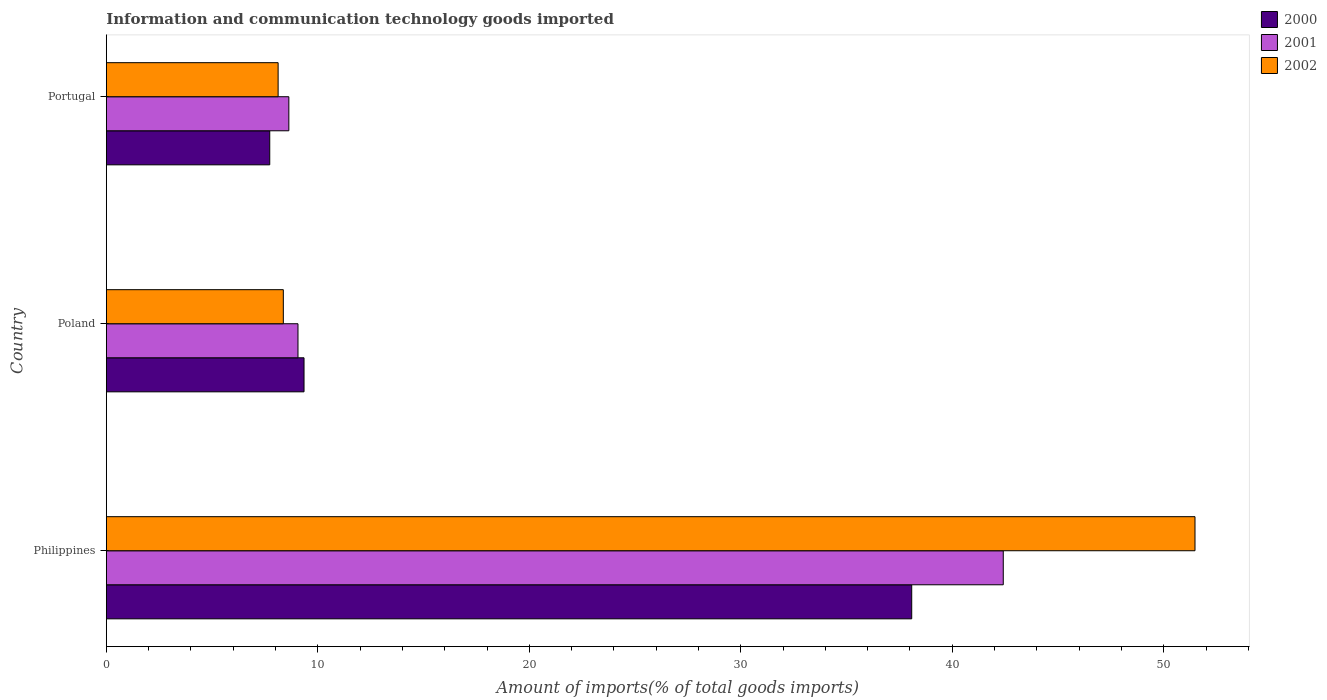How many different coloured bars are there?
Ensure brevity in your answer.  3. Are the number of bars on each tick of the Y-axis equal?
Give a very brief answer. Yes. What is the label of the 2nd group of bars from the top?
Your response must be concise. Poland. In how many cases, is the number of bars for a given country not equal to the number of legend labels?
Ensure brevity in your answer.  0. What is the amount of goods imported in 2000 in Philippines?
Provide a succinct answer. 38.08. Across all countries, what is the maximum amount of goods imported in 2000?
Your response must be concise. 38.08. Across all countries, what is the minimum amount of goods imported in 2001?
Keep it short and to the point. 8.63. In which country was the amount of goods imported in 2000 minimum?
Provide a succinct answer. Portugal. What is the total amount of goods imported in 2001 in the graph?
Your answer should be very brief. 60.1. What is the difference between the amount of goods imported in 2000 in Poland and that in Portugal?
Offer a very short reply. 1.62. What is the difference between the amount of goods imported in 2000 in Poland and the amount of goods imported in 2001 in Philippines?
Provide a succinct answer. -33.06. What is the average amount of goods imported in 2001 per country?
Make the answer very short. 20.03. What is the difference between the amount of goods imported in 2000 and amount of goods imported in 2002 in Portugal?
Offer a very short reply. -0.4. What is the ratio of the amount of goods imported in 2002 in Philippines to that in Portugal?
Make the answer very short. 6.34. Is the difference between the amount of goods imported in 2000 in Philippines and Portugal greater than the difference between the amount of goods imported in 2002 in Philippines and Portugal?
Provide a succinct answer. No. What is the difference between the highest and the second highest amount of goods imported in 2000?
Give a very brief answer. 28.73. What is the difference between the highest and the lowest amount of goods imported in 2001?
Your response must be concise. 33.78. In how many countries, is the amount of goods imported in 2002 greater than the average amount of goods imported in 2002 taken over all countries?
Offer a very short reply. 1. What does the 2nd bar from the top in Poland represents?
Offer a very short reply. 2001. Is it the case that in every country, the sum of the amount of goods imported in 2002 and amount of goods imported in 2000 is greater than the amount of goods imported in 2001?
Provide a succinct answer. Yes. How many bars are there?
Provide a short and direct response. 9. Are the values on the major ticks of X-axis written in scientific E-notation?
Ensure brevity in your answer.  No. Where does the legend appear in the graph?
Your answer should be compact. Top right. How are the legend labels stacked?
Keep it short and to the point. Vertical. What is the title of the graph?
Keep it short and to the point. Information and communication technology goods imported. Does "2009" appear as one of the legend labels in the graph?
Provide a succinct answer. No. What is the label or title of the X-axis?
Offer a terse response. Amount of imports(% of total goods imports). What is the label or title of the Y-axis?
Ensure brevity in your answer.  Country. What is the Amount of imports(% of total goods imports) of 2000 in Philippines?
Your answer should be very brief. 38.08. What is the Amount of imports(% of total goods imports) of 2001 in Philippines?
Keep it short and to the point. 42.41. What is the Amount of imports(% of total goods imports) in 2002 in Philippines?
Provide a short and direct response. 51.48. What is the Amount of imports(% of total goods imports) of 2000 in Poland?
Keep it short and to the point. 9.35. What is the Amount of imports(% of total goods imports) in 2001 in Poland?
Give a very brief answer. 9.06. What is the Amount of imports(% of total goods imports) of 2002 in Poland?
Your answer should be very brief. 8.37. What is the Amount of imports(% of total goods imports) of 2000 in Portugal?
Provide a short and direct response. 7.73. What is the Amount of imports(% of total goods imports) of 2001 in Portugal?
Keep it short and to the point. 8.63. What is the Amount of imports(% of total goods imports) of 2002 in Portugal?
Your answer should be compact. 8.12. Across all countries, what is the maximum Amount of imports(% of total goods imports) in 2000?
Your answer should be very brief. 38.08. Across all countries, what is the maximum Amount of imports(% of total goods imports) in 2001?
Offer a very short reply. 42.41. Across all countries, what is the maximum Amount of imports(% of total goods imports) in 2002?
Offer a terse response. 51.48. Across all countries, what is the minimum Amount of imports(% of total goods imports) in 2000?
Keep it short and to the point. 7.73. Across all countries, what is the minimum Amount of imports(% of total goods imports) in 2001?
Provide a short and direct response. 8.63. Across all countries, what is the minimum Amount of imports(% of total goods imports) in 2002?
Your answer should be compact. 8.12. What is the total Amount of imports(% of total goods imports) in 2000 in the graph?
Your response must be concise. 55.16. What is the total Amount of imports(% of total goods imports) of 2001 in the graph?
Provide a succinct answer. 60.1. What is the total Amount of imports(% of total goods imports) of 2002 in the graph?
Give a very brief answer. 67.97. What is the difference between the Amount of imports(% of total goods imports) of 2000 in Philippines and that in Poland?
Give a very brief answer. 28.73. What is the difference between the Amount of imports(% of total goods imports) of 2001 in Philippines and that in Poland?
Provide a short and direct response. 33.35. What is the difference between the Amount of imports(% of total goods imports) of 2002 in Philippines and that in Poland?
Offer a very short reply. 43.11. What is the difference between the Amount of imports(% of total goods imports) of 2000 in Philippines and that in Portugal?
Give a very brief answer. 30.36. What is the difference between the Amount of imports(% of total goods imports) in 2001 in Philippines and that in Portugal?
Your answer should be very brief. 33.78. What is the difference between the Amount of imports(% of total goods imports) of 2002 in Philippines and that in Portugal?
Your answer should be compact. 43.35. What is the difference between the Amount of imports(% of total goods imports) of 2000 in Poland and that in Portugal?
Ensure brevity in your answer.  1.62. What is the difference between the Amount of imports(% of total goods imports) in 2001 in Poland and that in Portugal?
Your response must be concise. 0.43. What is the difference between the Amount of imports(% of total goods imports) in 2002 in Poland and that in Portugal?
Ensure brevity in your answer.  0.25. What is the difference between the Amount of imports(% of total goods imports) of 2000 in Philippines and the Amount of imports(% of total goods imports) of 2001 in Poland?
Offer a very short reply. 29.02. What is the difference between the Amount of imports(% of total goods imports) of 2000 in Philippines and the Amount of imports(% of total goods imports) of 2002 in Poland?
Give a very brief answer. 29.71. What is the difference between the Amount of imports(% of total goods imports) in 2001 in Philippines and the Amount of imports(% of total goods imports) in 2002 in Poland?
Your answer should be very brief. 34.04. What is the difference between the Amount of imports(% of total goods imports) of 2000 in Philippines and the Amount of imports(% of total goods imports) of 2001 in Portugal?
Provide a succinct answer. 29.45. What is the difference between the Amount of imports(% of total goods imports) in 2000 in Philippines and the Amount of imports(% of total goods imports) in 2002 in Portugal?
Keep it short and to the point. 29.96. What is the difference between the Amount of imports(% of total goods imports) of 2001 in Philippines and the Amount of imports(% of total goods imports) of 2002 in Portugal?
Provide a short and direct response. 34.29. What is the difference between the Amount of imports(% of total goods imports) in 2000 in Poland and the Amount of imports(% of total goods imports) in 2001 in Portugal?
Your response must be concise. 0.72. What is the difference between the Amount of imports(% of total goods imports) of 2000 in Poland and the Amount of imports(% of total goods imports) of 2002 in Portugal?
Your answer should be very brief. 1.23. What is the difference between the Amount of imports(% of total goods imports) of 2001 in Poland and the Amount of imports(% of total goods imports) of 2002 in Portugal?
Provide a succinct answer. 0.94. What is the average Amount of imports(% of total goods imports) in 2000 per country?
Your answer should be compact. 18.39. What is the average Amount of imports(% of total goods imports) of 2001 per country?
Give a very brief answer. 20.03. What is the average Amount of imports(% of total goods imports) in 2002 per country?
Provide a short and direct response. 22.66. What is the difference between the Amount of imports(% of total goods imports) in 2000 and Amount of imports(% of total goods imports) in 2001 in Philippines?
Provide a succinct answer. -4.33. What is the difference between the Amount of imports(% of total goods imports) of 2000 and Amount of imports(% of total goods imports) of 2002 in Philippines?
Your answer should be very brief. -13.39. What is the difference between the Amount of imports(% of total goods imports) in 2001 and Amount of imports(% of total goods imports) in 2002 in Philippines?
Provide a succinct answer. -9.07. What is the difference between the Amount of imports(% of total goods imports) of 2000 and Amount of imports(% of total goods imports) of 2001 in Poland?
Keep it short and to the point. 0.29. What is the difference between the Amount of imports(% of total goods imports) of 2000 and Amount of imports(% of total goods imports) of 2002 in Poland?
Ensure brevity in your answer.  0.98. What is the difference between the Amount of imports(% of total goods imports) in 2001 and Amount of imports(% of total goods imports) in 2002 in Poland?
Keep it short and to the point. 0.69. What is the difference between the Amount of imports(% of total goods imports) of 2000 and Amount of imports(% of total goods imports) of 2001 in Portugal?
Ensure brevity in your answer.  -0.9. What is the difference between the Amount of imports(% of total goods imports) of 2000 and Amount of imports(% of total goods imports) of 2002 in Portugal?
Your response must be concise. -0.4. What is the difference between the Amount of imports(% of total goods imports) of 2001 and Amount of imports(% of total goods imports) of 2002 in Portugal?
Offer a terse response. 0.51. What is the ratio of the Amount of imports(% of total goods imports) in 2000 in Philippines to that in Poland?
Ensure brevity in your answer.  4.07. What is the ratio of the Amount of imports(% of total goods imports) in 2001 in Philippines to that in Poland?
Give a very brief answer. 4.68. What is the ratio of the Amount of imports(% of total goods imports) of 2002 in Philippines to that in Poland?
Provide a short and direct response. 6.15. What is the ratio of the Amount of imports(% of total goods imports) of 2000 in Philippines to that in Portugal?
Offer a very short reply. 4.93. What is the ratio of the Amount of imports(% of total goods imports) in 2001 in Philippines to that in Portugal?
Offer a very short reply. 4.91. What is the ratio of the Amount of imports(% of total goods imports) of 2002 in Philippines to that in Portugal?
Offer a terse response. 6.34. What is the ratio of the Amount of imports(% of total goods imports) of 2000 in Poland to that in Portugal?
Your response must be concise. 1.21. What is the ratio of the Amount of imports(% of total goods imports) in 2001 in Poland to that in Portugal?
Provide a succinct answer. 1.05. What is the ratio of the Amount of imports(% of total goods imports) in 2002 in Poland to that in Portugal?
Ensure brevity in your answer.  1.03. What is the difference between the highest and the second highest Amount of imports(% of total goods imports) of 2000?
Your response must be concise. 28.73. What is the difference between the highest and the second highest Amount of imports(% of total goods imports) in 2001?
Provide a succinct answer. 33.35. What is the difference between the highest and the second highest Amount of imports(% of total goods imports) of 2002?
Make the answer very short. 43.11. What is the difference between the highest and the lowest Amount of imports(% of total goods imports) of 2000?
Offer a terse response. 30.36. What is the difference between the highest and the lowest Amount of imports(% of total goods imports) in 2001?
Give a very brief answer. 33.78. What is the difference between the highest and the lowest Amount of imports(% of total goods imports) of 2002?
Make the answer very short. 43.35. 